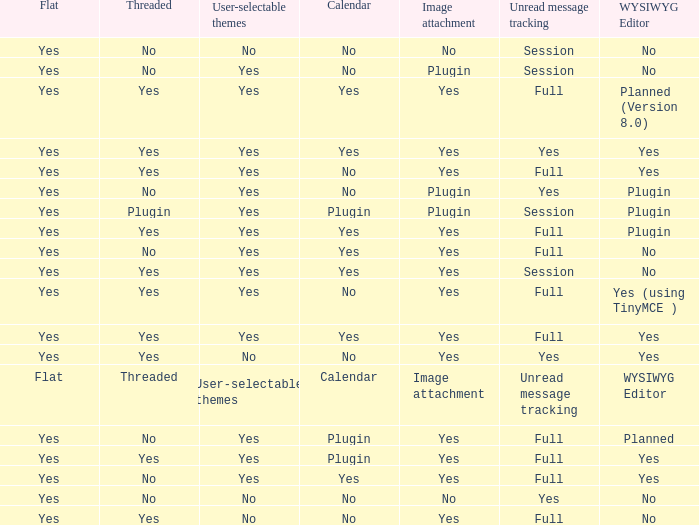Which Image attachment has a Threaded of yes, and a Calendar of yes? Yes, Yes, Yes, Yes, Yes. Could you parse the entire table? {'header': ['Flat', 'Threaded', 'User-selectable themes', 'Calendar', 'Image attachment', 'Unread message tracking', 'WYSIWYG Editor'], 'rows': [['Yes', 'No', 'No', 'No', 'No', 'Session', 'No'], ['Yes', 'No', 'Yes', 'No', 'Plugin', 'Session', 'No'], ['Yes', 'Yes', 'Yes', 'Yes', 'Yes', 'Full', 'Planned (Version 8.0)'], ['Yes', 'Yes', 'Yes', 'Yes', 'Yes', 'Yes', 'Yes'], ['Yes', 'Yes', 'Yes', 'No', 'Yes', 'Full', 'Yes'], ['Yes', 'No', 'Yes', 'No', 'Plugin', 'Yes', 'Plugin'], ['Yes', 'Plugin', 'Yes', 'Plugin', 'Plugin', 'Session', 'Plugin'], ['Yes', 'Yes', 'Yes', 'Yes', 'Yes', 'Full', 'Plugin'], ['Yes', 'No', 'Yes', 'Yes', 'Yes', 'Full', 'No'], ['Yes', 'Yes', 'Yes', 'Yes', 'Yes', 'Session', 'No'], ['Yes', 'Yes', 'Yes', 'No', 'Yes', 'Full', 'Yes (using TinyMCE )'], ['Yes', 'Yes', 'Yes', 'Yes', 'Yes', 'Full', 'Yes'], ['Yes', 'Yes', 'No', 'No', 'Yes', 'Yes', 'Yes'], ['Flat', 'Threaded', 'User-selectable themes', 'Calendar', 'Image attachment', 'Unread message tracking', 'WYSIWYG Editor'], ['Yes', 'No', 'Yes', 'Plugin', 'Yes', 'Full', 'Planned'], ['Yes', 'Yes', 'Yes', 'Plugin', 'Yes', 'Full', 'Yes'], ['Yes', 'No', 'Yes', 'Yes', 'Yes', 'Full', 'Yes'], ['Yes', 'No', 'No', 'No', 'No', 'Yes', 'No'], ['Yes', 'Yes', 'No', 'No', 'Yes', 'Full', 'No']]} 